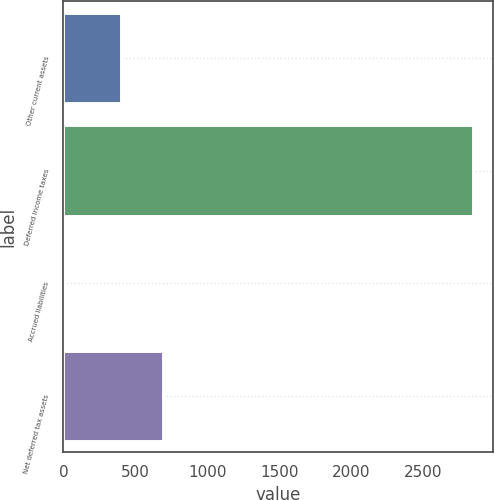Convert chart to OTSL. <chart><loc_0><loc_0><loc_500><loc_500><bar_chart><fcel>Other current assets<fcel>Deferred income taxes<fcel>Accrued liabilities<fcel>Net deferred tax assets<nl><fcel>398<fcel>2843<fcel>8<fcel>691.3<nl></chart> 